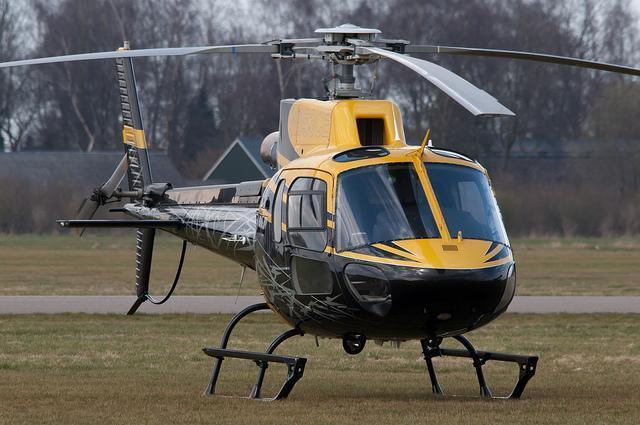How many tiger stripes are on the nose of the helicopter?
Give a very brief answer. 4. 